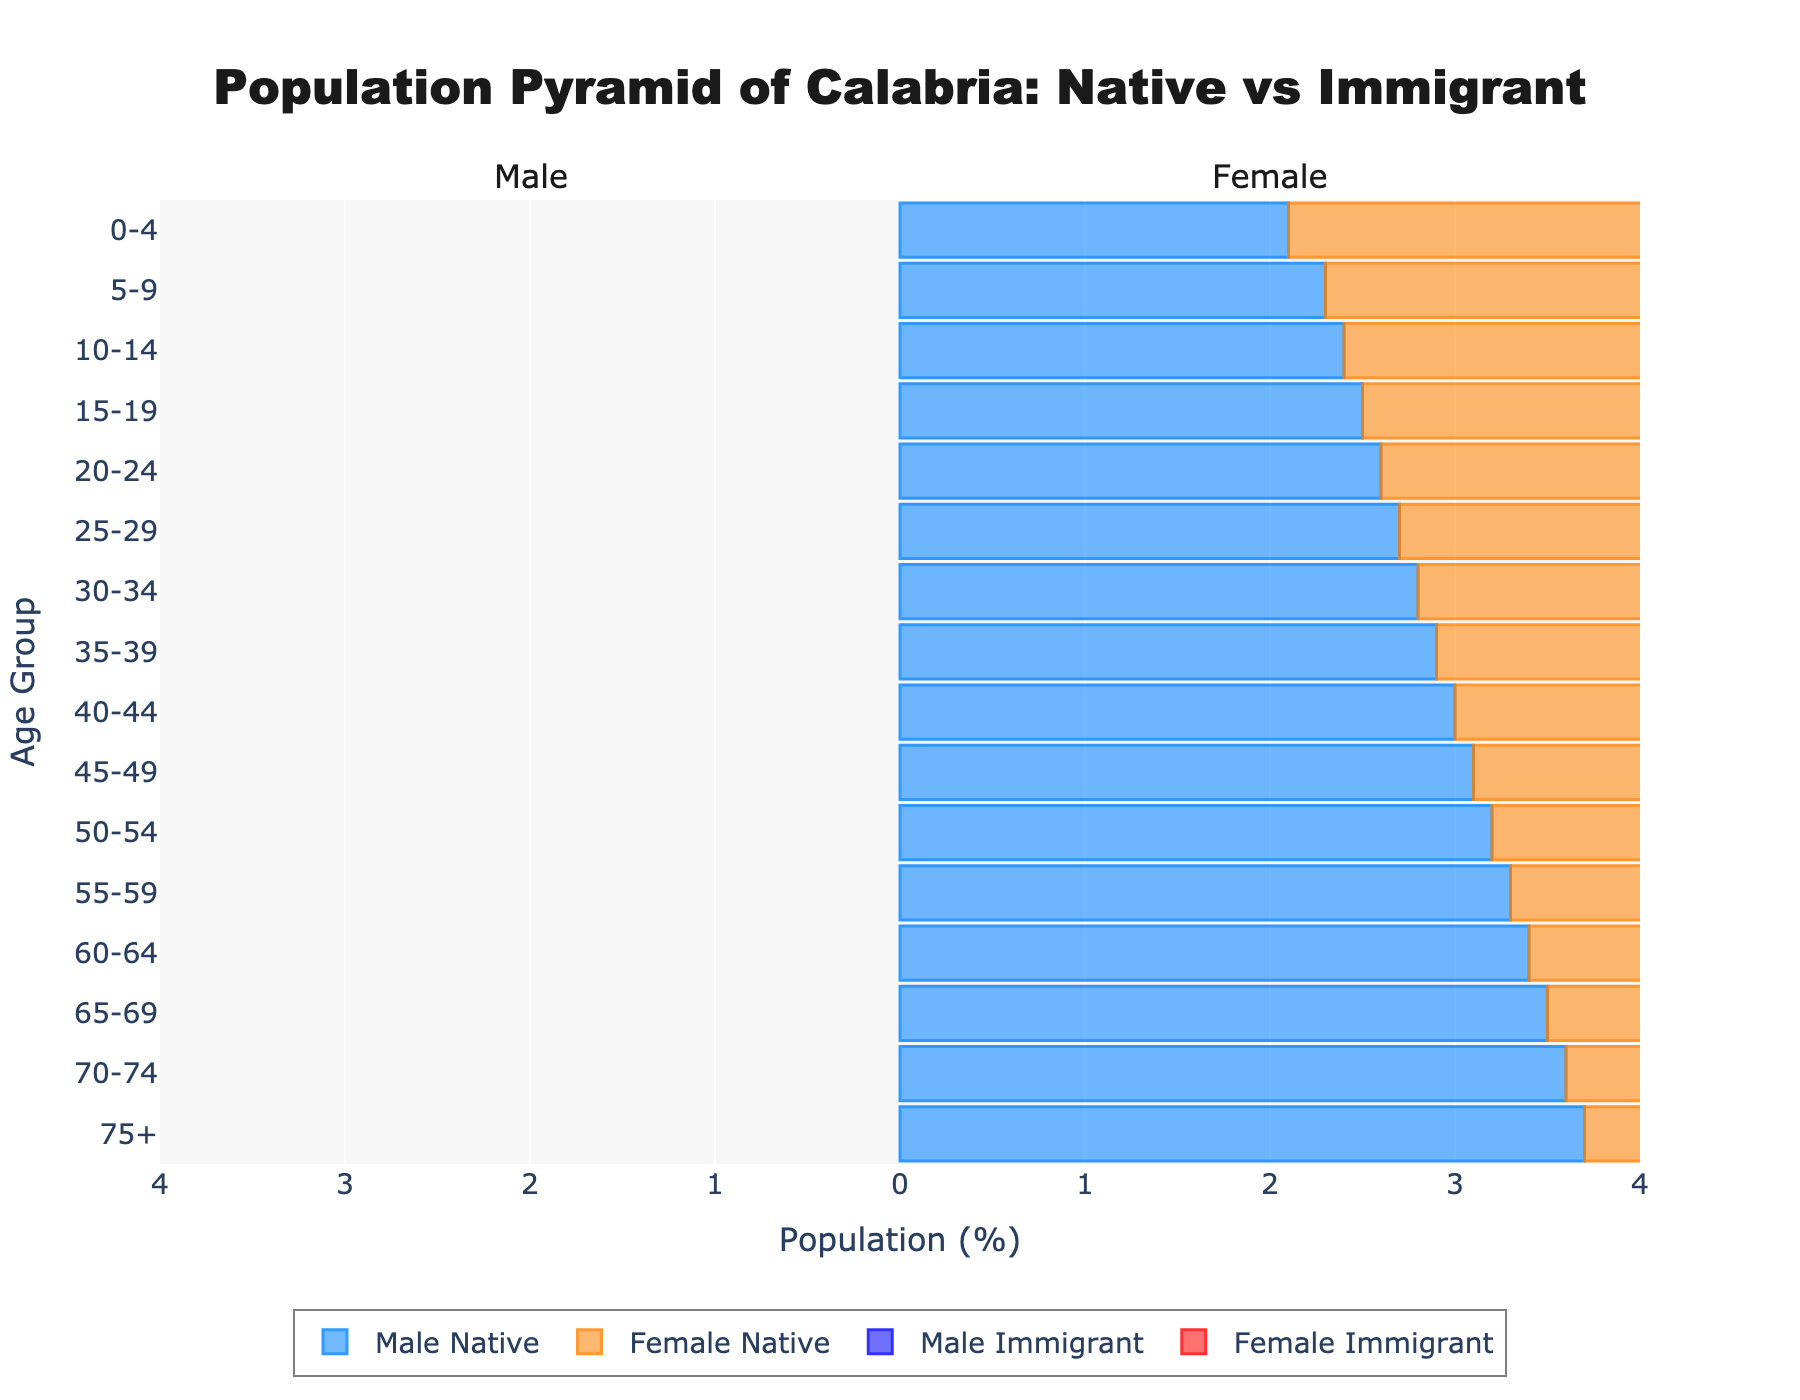How many age groups are represented in the population pyramid? There are distinct age groups listed on the y-axis, ranging from 0-4 to 75+. Counting these gives us the total number of age groups.
Answer: 16 Which age group has the highest proportion of male natives? By observing the length of the bars for male natives, the age group 75+ has the highest negative value, indicating the highest proportion.
Answer: 75+ What is the difference in the proportion of female natives and female immigrants in the 35-39 age group? The proportion of female natives in the 35-39 age group is 2.8, and for female immigrants, it is 1.2. Subtracting 1.2 from 2.8 gives the difference.
Answer: 1.6 Compare the male immigrant population in the 20-24 and 25-29 age groups. Which is larger? The proportion for male immigrants in the 20-24 age group is -0.8, while in the 25-29 age group, it is -1.0. The absolute value of -1.0 is larger than -0.8, indicating the 25-29 group is larger.
Answer: 25-29 Which gender has a higher native population proportion in the age group 50-54? By comparing the lengths of the bars, the male native proportion is -3.2, while the female native proportion is 3.1. The absolute value of -3.2 is greater, so males have a higher proportion.
Answer: Male In which age group is the proportion of male immigrants and female immigrants equal? Observing the chart, the proportions for both male and female immigrants are equal (0.1) in the 70-74 and 75+ age groups.
Answer: 70-74 and 75+ What is the total proportion of female natives across all age groups? Summing the values for female natives across all age groups: 2.0 + 2.2 + 2.3 + 2.4 + 2.5 + 2.6 + 2.7 + 2.8 + 2.9 + 3.0 + 3.1 + 3.2 + 3.3 + 3.4 + 3.5 + 3.6 = 47.5
Answer: 47.5 How does the proportion of male native population change as age increases from 5-9 to 60-64? The male native population proportion starts at -2.3 for age 5-9 and gradually decreases to -3.4 by age 60-64. The value consistently decreases as age increases.
Answer: Decreases Which age group has the smallest difference between male and female immigrant populations? The 0-4 age group has male immigrants at -0.2 and female immigrants at 0.2. The absolute difference is 0.4, the smallest compared to other age groups.
Answer: 0-4 Is the proportion of female immigrants in the 15-19 age group higher or lower compared to the female natives in the same age group? In the 15-19 age group, the proportion for female immigrants is 0.5, while for female natives, it is 2.4. 0.5 is lower than 2.4.
Answer: Lower 